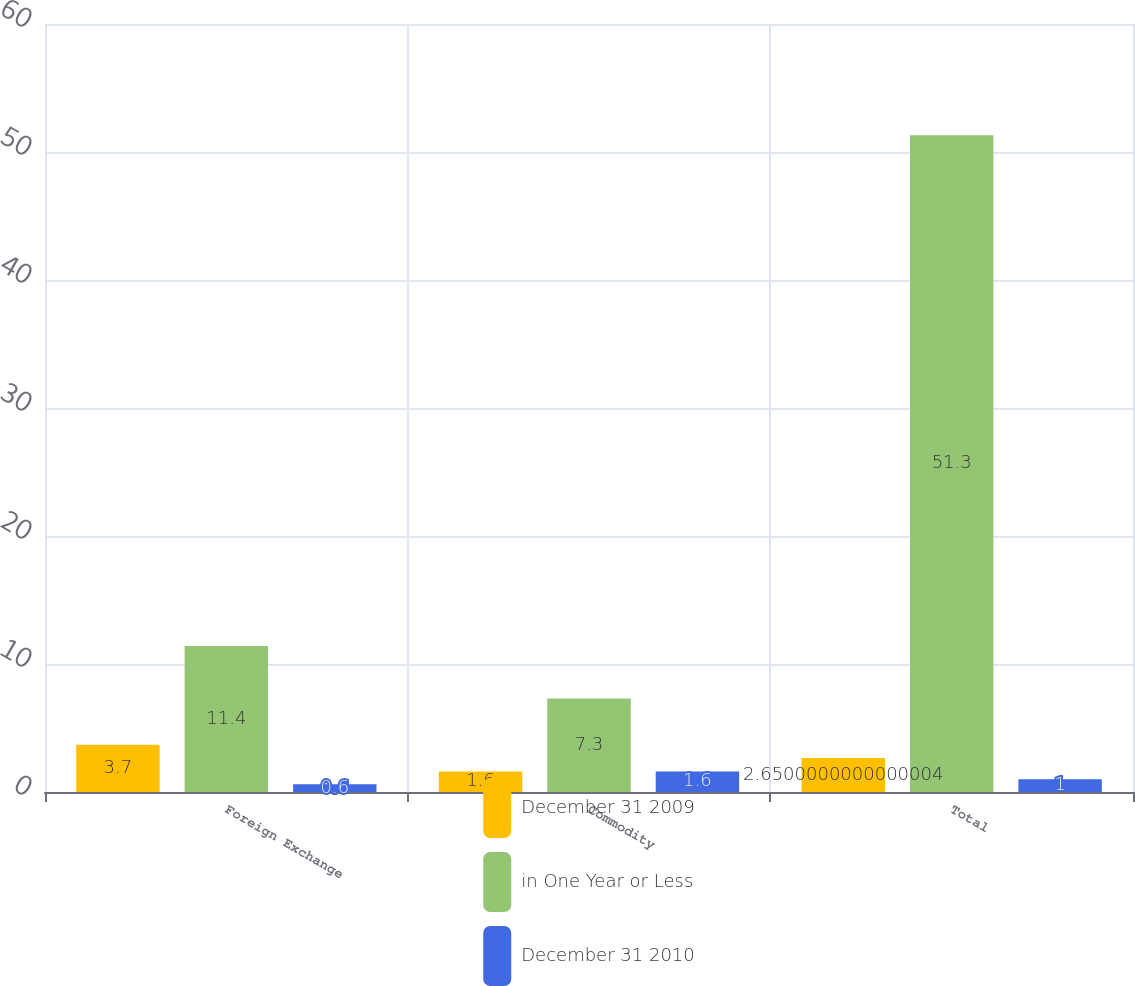Convert chart. <chart><loc_0><loc_0><loc_500><loc_500><stacked_bar_chart><ecel><fcel>Foreign Exchange<fcel>Commodity<fcel>Total<nl><fcel>December 31 2009<fcel>3.7<fcel>1.6<fcel>2.65<nl><fcel>in One Year or Less<fcel>11.4<fcel>7.3<fcel>51.3<nl><fcel>December 31 2010<fcel>0.6<fcel>1.6<fcel>1<nl></chart> 